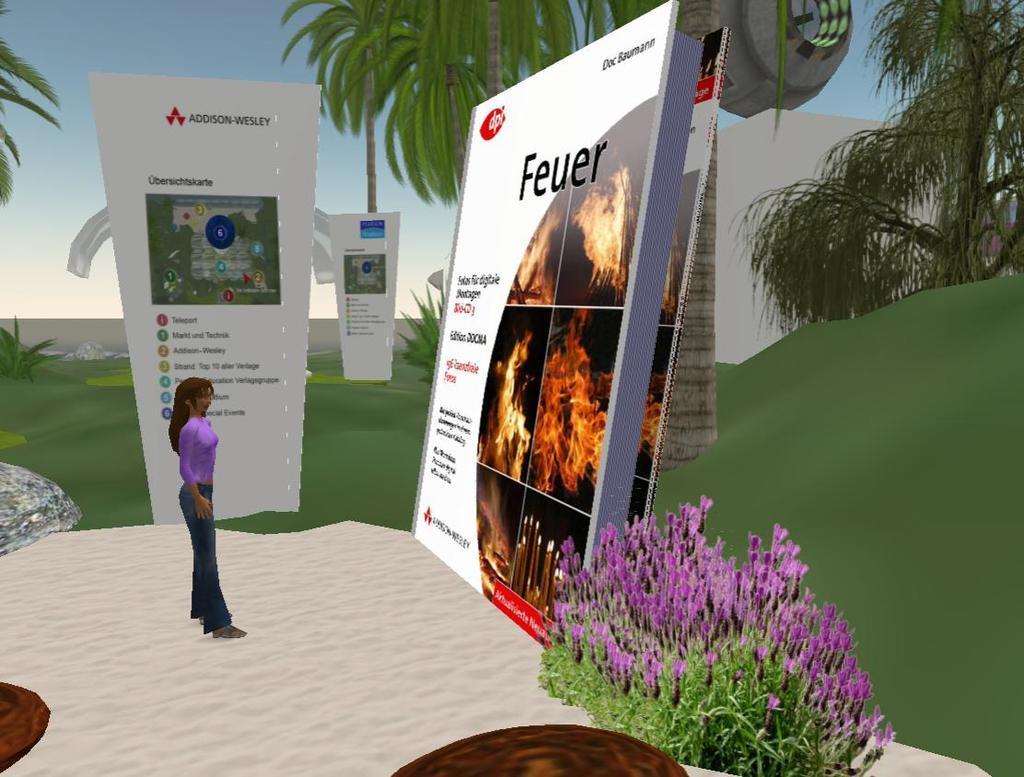Could you give a brief overview of what you see in this image? This image is an animated picture. On the left side of the image a lady is standing. In this we can see boards, trees, building, grass, plants with flowers, ground, wall stones are there. At the top of the image sky is there. 